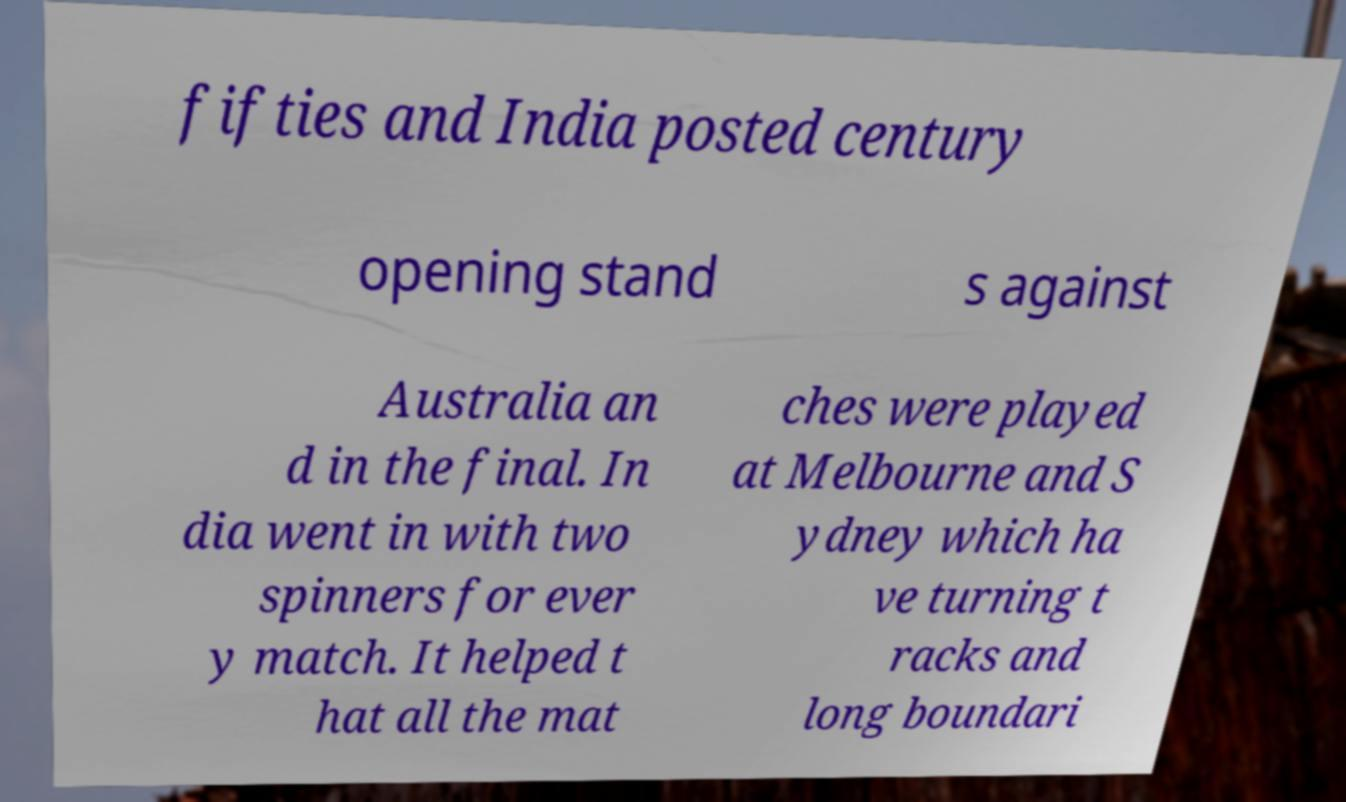Please identify and transcribe the text found in this image. fifties and India posted century opening stand s against Australia an d in the final. In dia went in with two spinners for ever y match. It helped t hat all the mat ches were played at Melbourne and S ydney which ha ve turning t racks and long boundari 